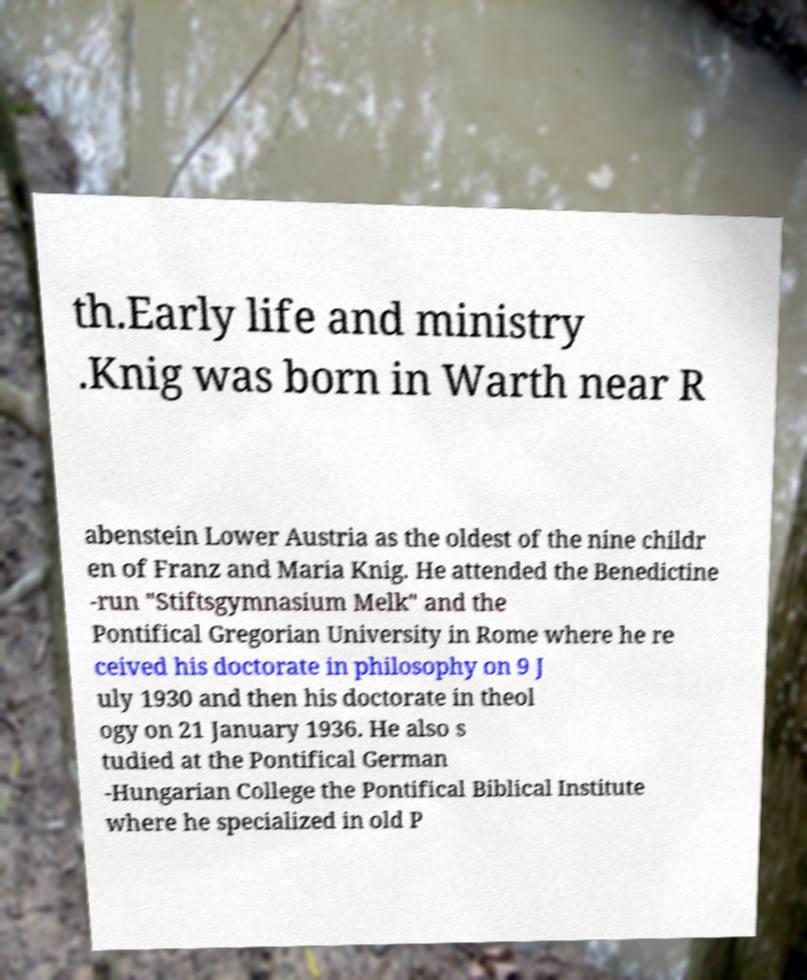Could you assist in decoding the text presented in this image and type it out clearly? th.Early life and ministry .Knig was born in Warth near R abenstein Lower Austria as the oldest of the nine childr en of Franz and Maria Knig. He attended the Benedictine -run "Stiftsgymnasium Melk" and the Pontifical Gregorian University in Rome where he re ceived his doctorate in philosophy on 9 J uly 1930 and then his doctorate in theol ogy on 21 January 1936. He also s tudied at the Pontifical German -Hungarian College the Pontifical Biblical Institute where he specialized in old P 